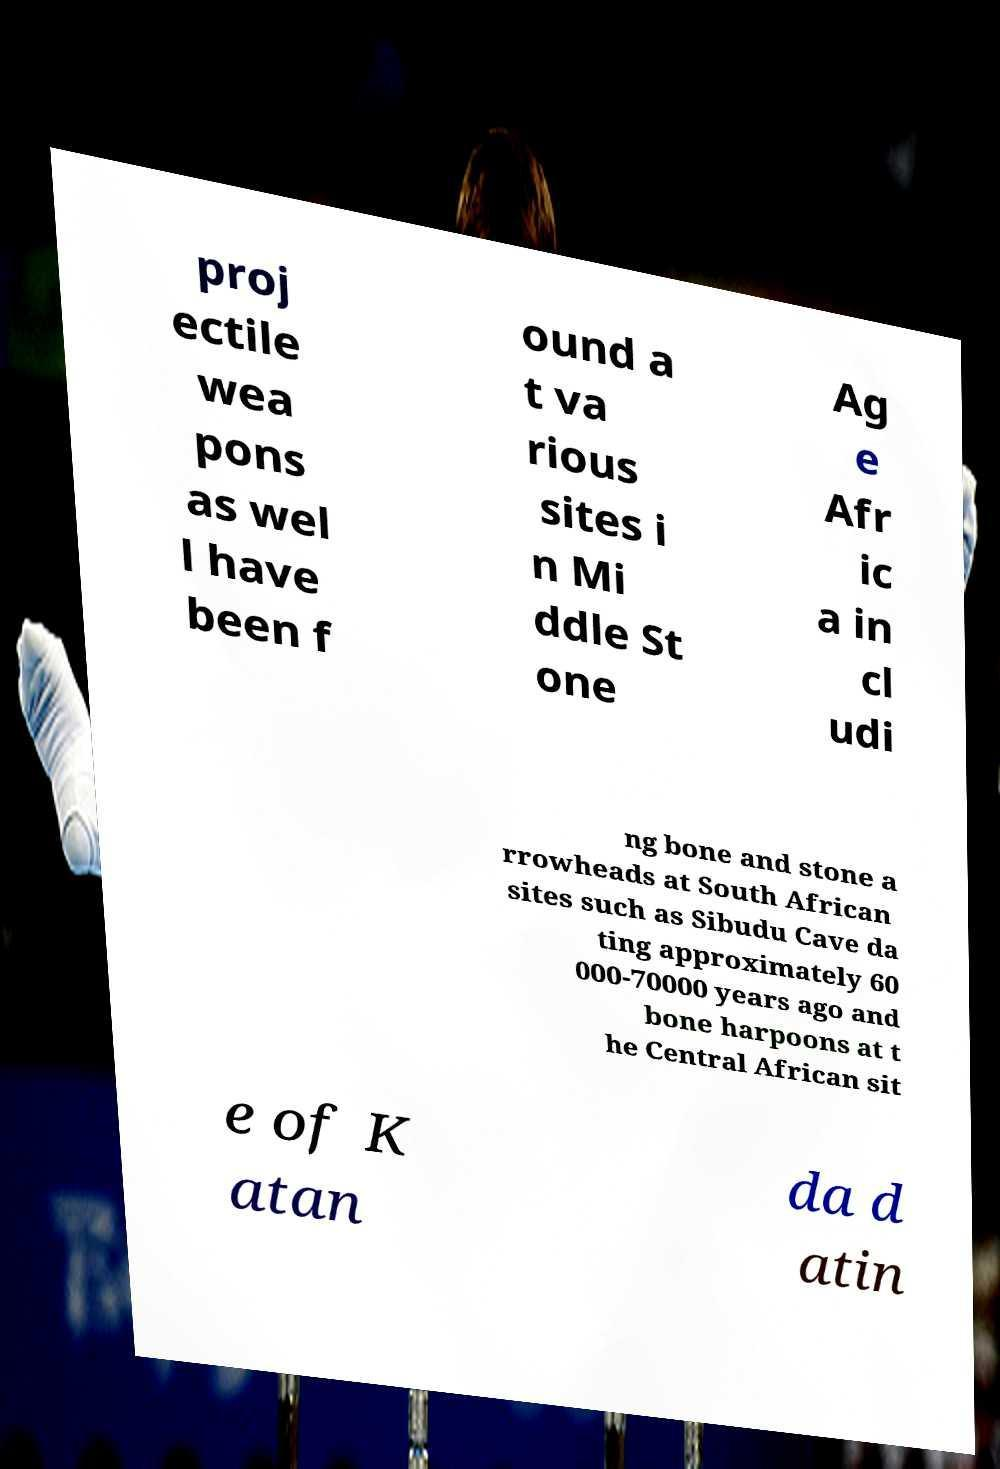I need the written content from this picture converted into text. Can you do that? proj ectile wea pons as wel l have been f ound a t va rious sites i n Mi ddle St one Ag e Afr ic a in cl udi ng bone and stone a rrowheads at South African sites such as Sibudu Cave da ting approximately 60 000-70000 years ago and bone harpoons at t he Central African sit e of K atan da d atin 